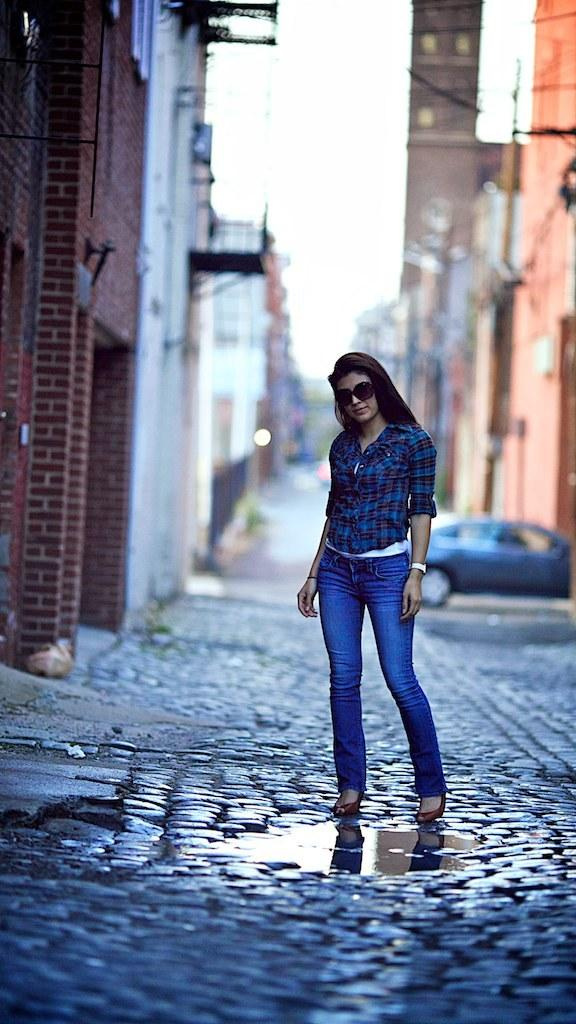Who is the main subject in the image? There is a woman in the image. What is the woman wearing? The woman is wearing jeans and a shirt. Where is the woman located in the image? The woman is standing on the street. What is the woman doing in the image? The woman is looking at someone. What type of idea is the woman holding in her hands in the image? There is no idea present in the image; it is a woman standing on the street and looking at someone. 